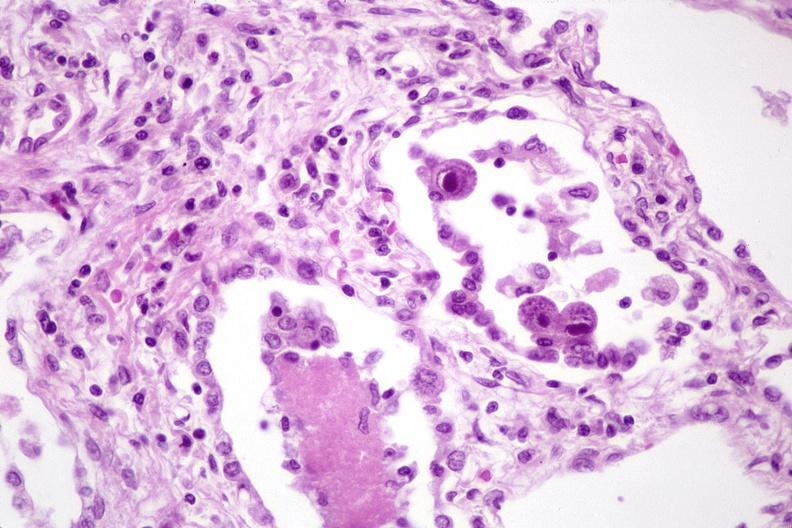s respiratory present?
Answer the question using a single word or phrase. Yes 